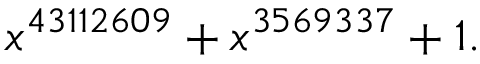Convert formula to latex. <formula><loc_0><loc_0><loc_500><loc_500>x ^ { 4 3 1 1 2 6 0 9 } + x ^ { 3 5 6 9 3 3 7 } + 1 .</formula> 